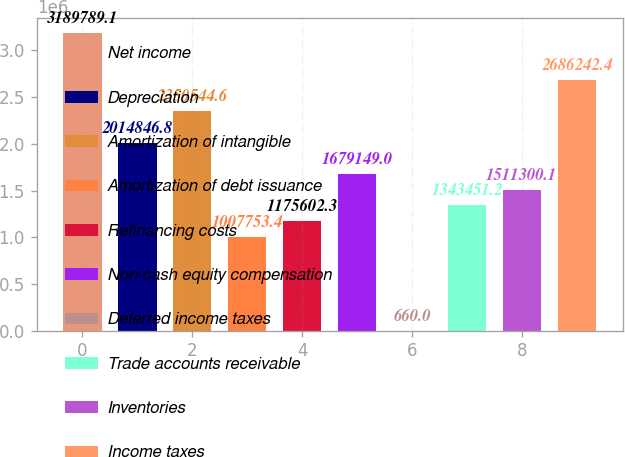Convert chart to OTSL. <chart><loc_0><loc_0><loc_500><loc_500><bar_chart><fcel>Net income<fcel>Depreciation<fcel>Amortization of intangible<fcel>Amortization of debt issuance<fcel>Refinancing costs<fcel>Non-cash equity compensation<fcel>Deferred income taxes<fcel>Trade accounts receivable<fcel>Inventories<fcel>Income taxes<nl><fcel>3.18979e+06<fcel>2.01485e+06<fcel>2.35054e+06<fcel>1.00775e+06<fcel>1.1756e+06<fcel>1.67915e+06<fcel>660<fcel>1.34345e+06<fcel>1.5113e+06<fcel>2.68624e+06<nl></chart> 